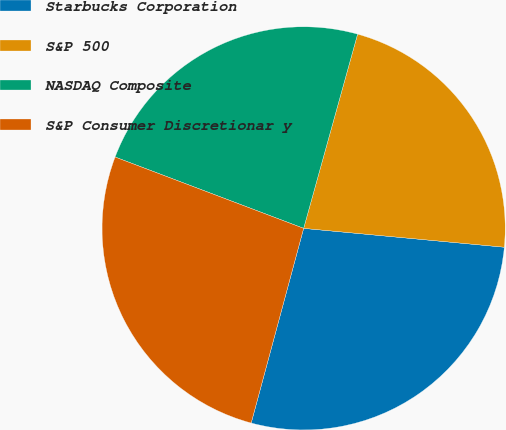<chart> <loc_0><loc_0><loc_500><loc_500><pie_chart><fcel>Starbucks Corporation<fcel>S&P 500<fcel>NASDAQ Composite<fcel>S&P Consumer Discretionar y<nl><fcel>27.7%<fcel>22.18%<fcel>23.56%<fcel>26.57%<nl></chart> 